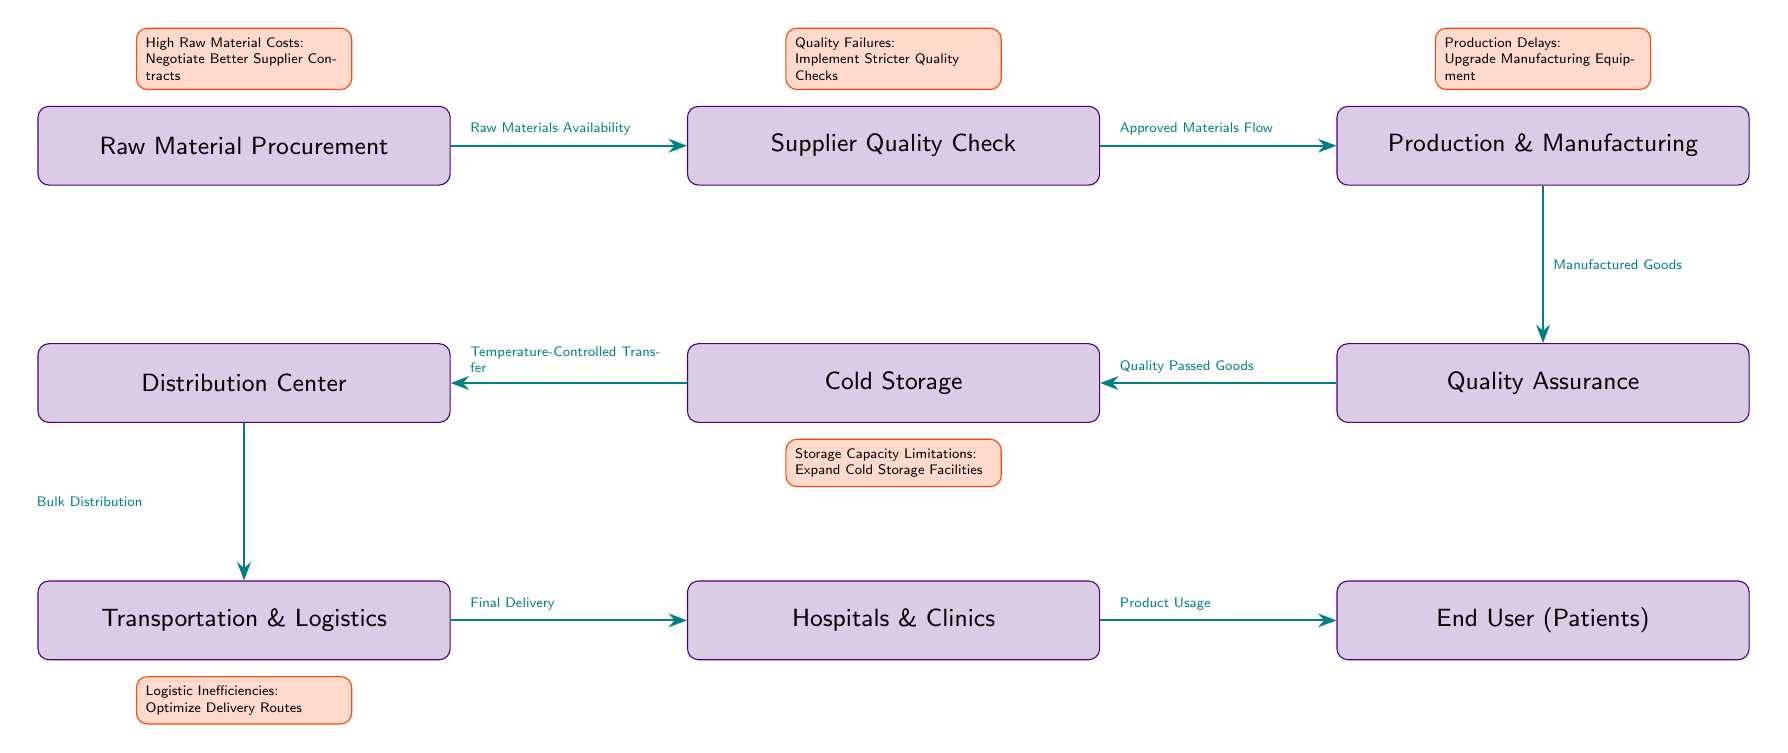What is the first stage in the supply chain? The first stage in the supply chain is represented by the node "Raw Material Procurement." This is the starting point where all materials are gathered for further processing.
Answer: Raw Material Procurement How many nodes are there in the diagram? To determine the number of nodes, we can count each distinct block representing a stage in the supply chain. The diagram has eight nodes: Raw Material Procurement, Supplier Quality Check, Production & Manufacturing, Quality Assurance, Cold Storage, Distribution Center, Transportation & Logistics, Hospitals & Clinics, and End User (Patients). Thus, the total is nine nodes.
Answer: Nine What type of goods flow from Production & Manufacturing to Quality Assurance? The type of goods flowing from Production & Manufacturing to Quality Assurance is "Manufactured Goods." This flow represents what is produced and needs to be assessed for quality.
Answer: Manufactured Goods What potential optimization is suggested for the supplier quality check? The suggested optimization for the supplier quality check is "Implement Stricter Quality Checks." This suggestion aims to reduce quality failures observed in the process.
Answer: Implement Stricter Quality Checks What stage follows Cold Storage? The stage that follows Cold Storage is the Distribution Center. This node indicates the next step where refrigerated goods are moved to a centralized distribution area.
Answer: Distribution Center What logistic issue is identified in the transportation stage? The identified logistic issue in the transportation stage is "Optimize Delivery Routes." This is aimed at addressing inefficiencies during product delivery to the end-user.
Answer: Optimize Delivery Routes What area shows a need for expansion due to limitations? The area that shows a need for expansion due to limitations is "Cold Storage." The diagram indicates that there are storage capacity limitations that could be mitigated by increasing the facilities.
Answer: Expand Cold Storage Facilities How do the hospitals and clinics relate to the end user? The relationship is that Hospitals & Clinics are the intermediary stage that delivers the products to the End User (Patients). This indicates that patients access the biomedical products through these healthcare facilities.
Answer: Hospitals & Clinics What flows from the Distribution Center to Transportation & Logistics? The flow from the Distribution Center to Transportation & Logistics is "Bulk Distribution." This term represents the transfer of large quantities of goods to the next stage.
Answer: Bulk Distribution 